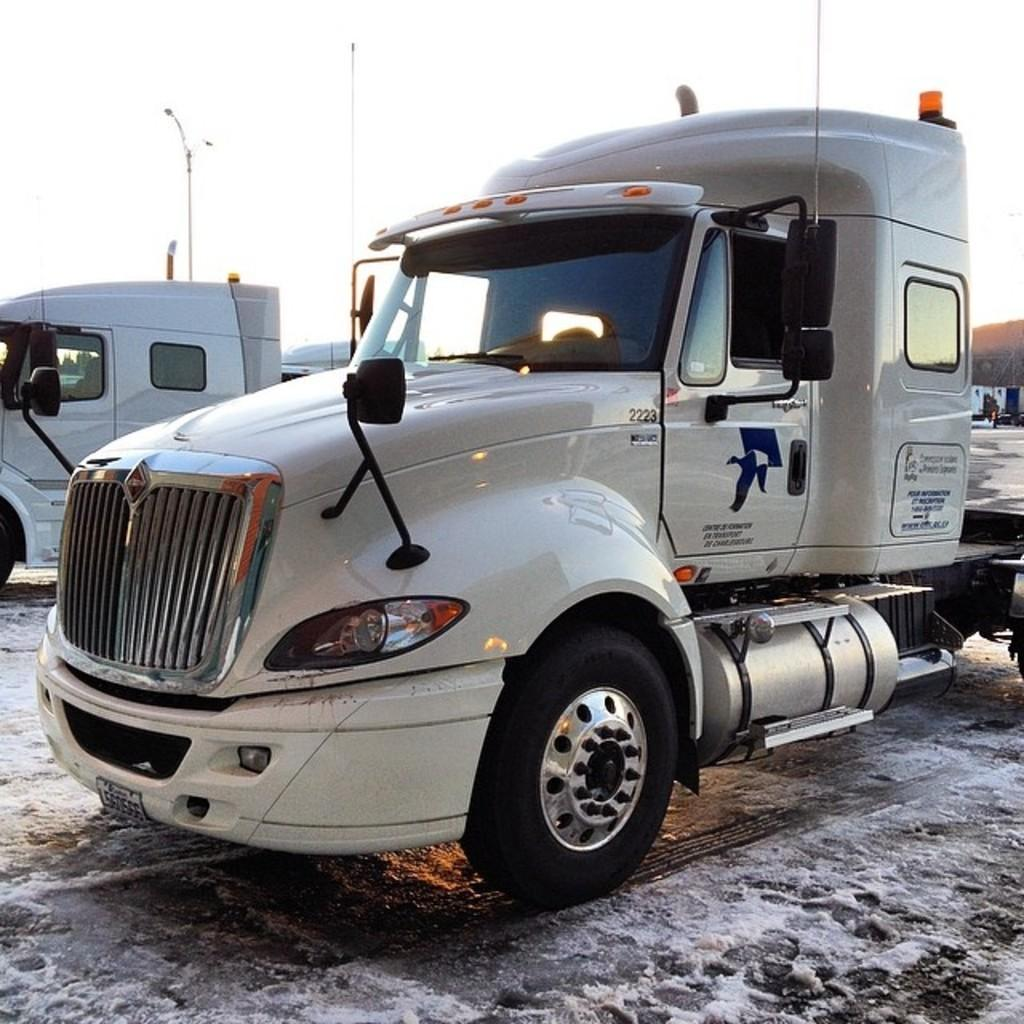What types of objects can be seen in the image? There are vehicles in the image. What can be seen in the background of the image? The sky is visible in the background of the image. How many geese are flying in the sky in the image? There are no geese visible in the image; only vehicles and the sky are present. What type of print is visible on the vehicles in the image? There is no information about the print on the vehicles in the image. 